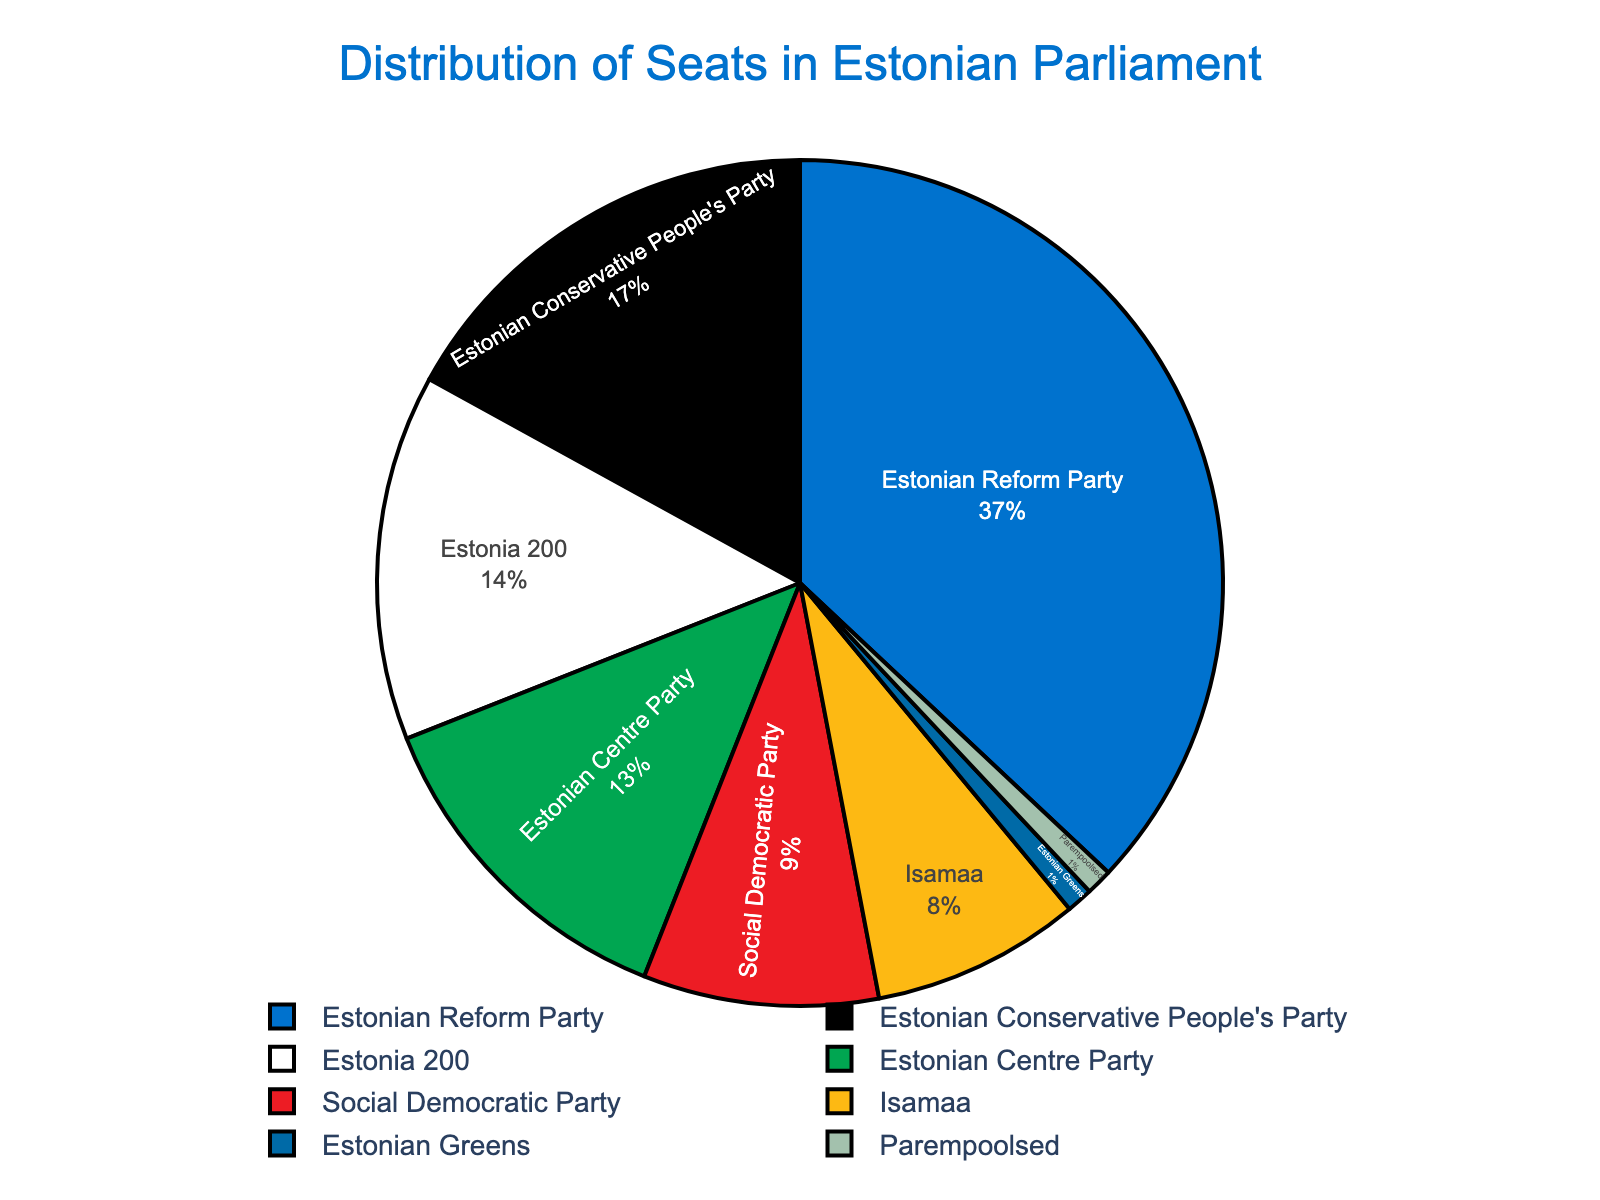Which party has the most seats in the Estonian Parliament? Looking at the figure, identify the party with the largest segment.
Answer: Estonian Reform Party How many seats do the Social Democratic Party and Isamaa have in total? Sum the seats of Social Democratic Party (9) and Isamaa (8): 9 + 8.
Answer: 17 Which party has the least representation in the Estonian Parliament? Identify the party with the smallest segment.
Answer: Parempoolsed How many seats are held by the Estonian Greens compared to those held by Estonia 200? Compare the segments of Estonian Greens (1) and Estonia 200 (14).
Answer: Estonian Greens have 1, while Estonia 200 has 14 What percentage of the seats does the Estonian Reform Party hold? Calculate the percentage of seats: (37/100) * 100.
Answer: 37% Are there more seats held by the Estonian Centre Party or by the Social Democratic Party and Estonian Greens combined? Compare the seats of the Estonian Centre Party (13) with the sum of Social Democratic Party (9) and Estonian Greens (1): 9 + 1 = 10.
Answer: Estonian Centre Party What proportion of the seats is held by parties with 10 or fewer seats each? Sum the seats for parties with 10 or fewer seats (Estonian Conservative People's Party (17), Estonia 200 (14), Estonian Centre Party (13) are excluded): Social Democratic Party (9) + Isamaa (8) + Estonian Greens (1) + Parempoolsed (1): 9 + 8 + 1 + 1 = 19. Then, find the percentage: (19/100) * 100.
Answer: 19% Which party holds a number of seats closest to the average number of seats per party? First, calculate the total number of seats: 37 + 17 + 14 + 13 + 9 + 8 + 1 + 1 = 100. Then, find the average: 100 / 8 = 12.5. Compare each party's seats to 12.5 and find the closest one.
Answer: Estonian Centre Party (closest with 13) How do the combined seats of the Estonian Conservative People's Party and Estonia 200 compare to those of the Estonian Reform Party? Add seats of Estonian Conservative People's Party (17) and Estonia 200 (14): 17 + 14 = 31. Compare with Estonian Reform Party's seats: 31 < 37.
Answer: Estonian Reform Party has more seats If the Estonian Reform Party and Isamaa formed a coalition, how many seats would they have together? Add the seats of Estonian Reform Party (37) and Isamaa (8): 37 + 8.
Answer: 45 